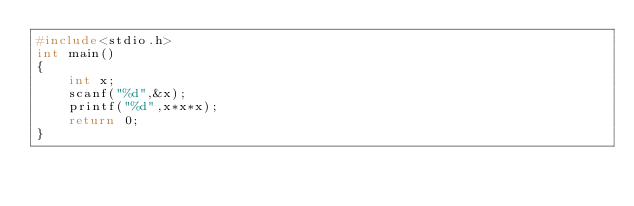<code> <loc_0><loc_0><loc_500><loc_500><_C_>#include<stdio.h>
int main()
{
    int x;
    scanf("%d",&x);
    printf("%d",x*x*x);
    return 0;
}

</code> 